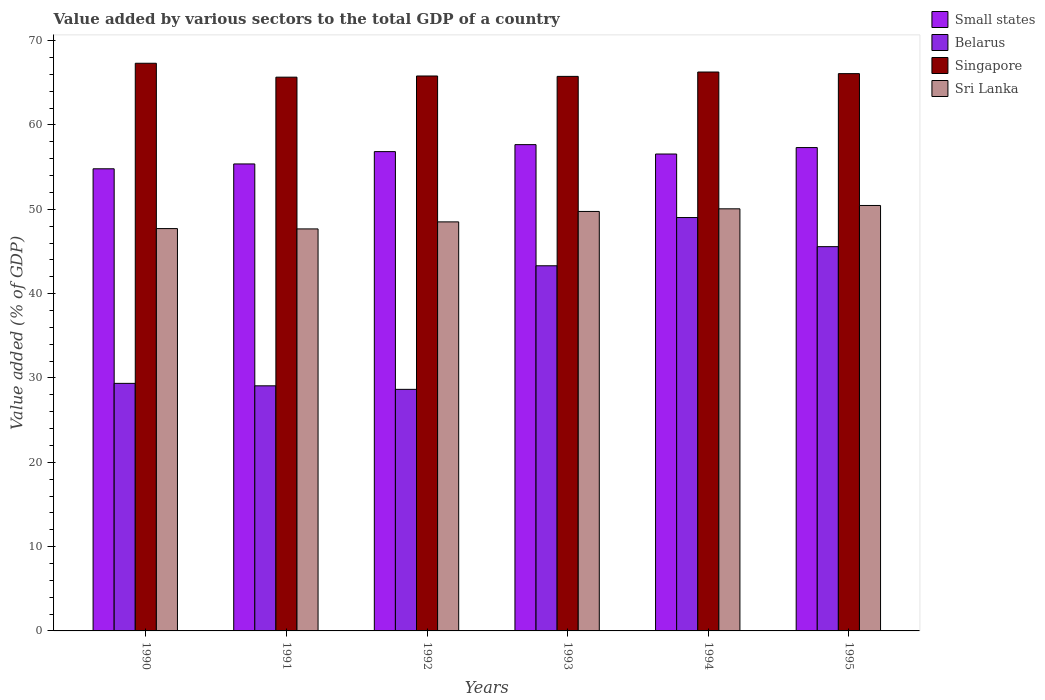Are the number of bars on each tick of the X-axis equal?
Offer a very short reply. Yes. How many bars are there on the 3rd tick from the right?
Make the answer very short. 4. In how many cases, is the number of bars for a given year not equal to the number of legend labels?
Your response must be concise. 0. What is the value added by various sectors to the total GDP in Singapore in 1990?
Ensure brevity in your answer.  67.32. Across all years, what is the maximum value added by various sectors to the total GDP in Belarus?
Make the answer very short. 49.02. Across all years, what is the minimum value added by various sectors to the total GDP in Sri Lanka?
Your answer should be compact. 47.68. In which year was the value added by various sectors to the total GDP in Singapore maximum?
Keep it short and to the point. 1990. In which year was the value added by various sectors to the total GDP in Belarus minimum?
Offer a terse response. 1992. What is the total value added by various sectors to the total GDP in Belarus in the graph?
Give a very brief answer. 224.97. What is the difference between the value added by various sectors to the total GDP in Small states in 1990 and that in 1993?
Give a very brief answer. -2.86. What is the difference between the value added by various sectors to the total GDP in Small states in 1993 and the value added by various sectors to the total GDP in Sri Lanka in 1994?
Your answer should be compact. 7.61. What is the average value added by various sectors to the total GDP in Sri Lanka per year?
Keep it short and to the point. 49.03. In the year 1992, what is the difference between the value added by various sectors to the total GDP in Small states and value added by various sectors to the total GDP in Sri Lanka?
Offer a terse response. 8.33. In how many years, is the value added by various sectors to the total GDP in Singapore greater than 54 %?
Keep it short and to the point. 6. What is the ratio of the value added by various sectors to the total GDP in Sri Lanka in 1993 to that in 1995?
Provide a short and direct response. 0.99. What is the difference between the highest and the second highest value added by various sectors to the total GDP in Belarus?
Provide a short and direct response. 3.45. What is the difference between the highest and the lowest value added by various sectors to the total GDP in Sri Lanka?
Offer a very short reply. 2.78. In how many years, is the value added by various sectors to the total GDP in Belarus greater than the average value added by various sectors to the total GDP in Belarus taken over all years?
Ensure brevity in your answer.  3. Is the sum of the value added by various sectors to the total GDP in Singapore in 1993 and 1995 greater than the maximum value added by various sectors to the total GDP in Belarus across all years?
Your answer should be very brief. Yes. What does the 4th bar from the left in 1991 represents?
Offer a very short reply. Sri Lanka. What does the 3rd bar from the right in 1992 represents?
Provide a succinct answer. Belarus. Are all the bars in the graph horizontal?
Your answer should be compact. No. What is the difference between two consecutive major ticks on the Y-axis?
Provide a succinct answer. 10. Does the graph contain grids?
Give a very brief answer. No. Where does the legend appear in the graph?
Provide a succinct answer. Top right. How many legend labels are there?
Your response must be concise. 4. How are the legend labels stacked?
Offer a terse response. Vertical. What is the title of the graph?
Your answer should be compact. Value added by various sectors to the total GDP of a country. Does "Turkey" appear as one of the legend labels in the graph?
Offer a terse response. No. What is the label or title of the Y-axis?
Provide a short and direct response. Value added (% of GDP). What is the Value added (% of GDP) of Small states in 1990?
Keep it short and to the point. 54.8. What is the Value added (% of GDP) of Belarus in 1990?
Provide a short and direct response. 29.36. What is the Value added (% of GDP) in Singapore in 1990?
Your response must be concise. 67.32. What is the Value added (% of GDP) of Sri Lanka in 1990?
Give a very brief answer. 47.71. What is the Value added (% of GDP) of Small states in 1991?
Offer a terse response. 55.38. What is the Value added (% of GDP) of Belarus in 1991?
Your answer should be very brief. 29.07. What is the Value added (% of GDP) of Singapore in 1991?
Offer a very short reply. 65.67. What is the Value added (% of GDP) in Sri Lanka in 1991?
Your answer should be compact. 47.68. What is the Value added (% of GDP) of Small states in 1992?
Your answer should be compact. 56.84. What is the Value added (% of GDP) of Belarus in 1992?
Offer a terse response. 28.65. What is the Value added (% of GDP) in Singapore in 1992?
Ensure brevity in your answer.  65.81. What is the Value added (% of GDP) of Sri Lanka in 1992?
Keep it short and to the point. 48.51. What is the Value added (% of GDP) in Small states in 1993?
Provide a succinct answer. 57.67. What is the Value added (% of GDP) in Belarus in 1993?
Provide a succinct answer. 43.3. What is the Value added (% of GDP) in Singapore in 1993?
Offer a terse response. 65.76. What is the Value added (% of GDP) of Sri Lanka in 1993?
Provide a short and direct response. 49.75. What is the Value added (% of GDP) of Small states in 1994?
Your response must be concise. 56.56. What is the Value added (% of GDP) in Belarus in 1994?
Your answer should be compact. 49.02. What is the Value added (% of GDP) in Singapore in 1994?
Provide a succinct answer. 66.28. What is the Value added (% of GDP) in Sri Lanka in 1994?
Provide a succinct answer. 50.06. What is the Value added (% of GDP) in Small states in 1995?
Keep it short and to the point. 57.32. What is the Value added (% of GDP) in Belarus in 1995?
Your answer should be very brief. 45.57. What is the Value added (% of GDP) in Singapore in 1995?
Your answer should be very brief. 66.09. What is the Value added (% of GDP) in Sri Lanka in 1995?
Provide a short and direct response. 50.46. Across all years, what is the maximum Value added (% of GDP) of Small states?
Keep it short and to the point. 57.67. Across all years, what is the maximum Value added (% of GDP) of Belarus?
Ensure brevity in your answer.  49.02. Across all years, what is the maximum Value added (% of GDP) of Singapore?
Give a very brief answer. 67.32. Across all years, what is the maximum Value added (% of GDP) in Sri Lanka?
Give a very brief answer. 50.46. Across all years, what is the minimum Value added (% of GDP) of Small states?
Your answer should be compact. 54.8. Across all years, what is the minimum Value added (% of GDP) of Belarus?
Provide a short and direct response. 28.65. Across all years, what is the minimum Value added (% of GDP) of Singapore?
Your answer should be compact. 65.67. Across all years, what is the minimum Value added (% of GDP) of Sri Lanka?
Offer a terse response. 47.68. What is the total Value added (% of GDP) in Small states in the graph?
Offer a very short reply. 338.57. What is the total Value added (% of GDP) in Belarus in the graph?
Keep it short and to the point. 224.97. What is the total Value added (% of GDP) of Singapore in the graph?
Make the answer very short. 396.94. What is the total Value added (% of GDP) of Sri Lanka in the graph?
Make the answer very short. 294.16. What is the difference between the Value added (% of GDP) in Small states in 1990 and that in 1991?
Provide a succinct answer. -0.58. What is the difference between the Value added (% of GDP) in Belarus in 1990 and that in 1991?
Your answer should be compact. 0.29. What is the difference between the Value added (% of GDP) in Singapore in 1990 and that in 1991?
Your response must be concise. 1.65. What is the difference between the Value added (% of GDP) in Sri Lanka in 1990 and that in 1991?
Ensure brevity in your answer.  0.04. What is the difference between the Value added (% of GDP) in Small states in 1990 and that in 1992?
Give a very brief answer. -2.04. What is the difference between the Value added (% of GDP) in Belarus in 1990 and that in 1992?
Make the answer very short. 0.71. What is the difference between the Value added (% of GDP) of Singapore in 1990 and that in 1992?
Your answer should be compact. 1.51. What is the difference between the Value added (% of GDP) in Sri Lanka in 1990 and that in 1992?
Your response must be concise. -0.8. What is the difference between the Value added (% of GDP) in Small states in 1990 and that in 1993?
Your answer should be very brief. -2.86. What is the difference between the Value added (% of GDP) of Belarus in 1990 and that in 1993?
Keep it short and to the point. -13.95. What is the difference between the Value added (% of GDP) in Singapore in 1990 and that in 1993?
Offer a very short reply. 1.56. What is the difference between the Value added (% of GDP) in Sri Lanka in 1990 and that in 1993?
Provide a succinct answer. -2.03. What is the difference between the Value added (% of GDP) of Small states in 1990 and that in 1994?
Keep it short and to the point. -1.75. What is the difference between the Value added (% of GDP) of Belarus in 1990 and that in 1994?
Provide a short and direct response. -19.67. What is the difference between the Value added (% of GDP) of Singapore in 1990 and that in 1994?
Your answer should be compact. 1.04. What is the difference between the Value added (% of GDP) of Sri Lanka in 1990 and that in 1994?
Ensure brevity in your answer.  -2.34. What is the difference between the Value added (% of GDP) of Small states in 1990 and that in 1995?
Keep it short and to the point. -2.52. What is the difference between the Value added (% of GDP) in Belarus in 1990 and that in 1995?
Give a very brief answer. -16.21. What is the difference between the Value added (% of GDP) of Singapore in 1990 and that in 1995?
Your answer should be compact. 1.23. What is the difference between the Value added (% of GDP) in Sri Lanka in 1990 and that in 1995?
Your answer should be compact. -2.74. What is the difference between the Value added (% of GDP) in Small states in 1991 and that in 1992?
Keep it short and to the point. -1.46. What is the difference between the Value added (% of GDP) in Belarus in 1991 and that in 1992?
Provide a short and direct response. 0.42. What is the difference between the Value added (% of GDP) of Singapore in 1991 and that in 1992?
Make the answer very short. -0.14. What is the difference between the Value added (% of GDP) of Sri Lanka in 1991 and that in 1992?
Provide a succinct answer. -0.83. What is the difference between the Value added (% of GDP) in Small states in 1991 and that in 1993?
Offer a very short reply. -2.29. What is the difference between the Value added (% of GDP) in Belarus in 1991 and that in 1993?
Your answer should be compact. -14.24. What is the difference between the Value added (% of GDP) of Singapore in 1991 and that in 1993?
Your answer should be compact. -0.09. What is the difference between the Value added (% of GDP) of Sri Lanka in 1991 and that in 1993?
Provide a short and direct response. -2.07. What is the difference between the Value added (% of GDP) in Small states in 1991 and that in 1994?
Ensure brevity in your answer.  -1.18. What is the difference between the Value added (% of GDP) in Belarus in 1991 and that in 1994?
Ensure brevity in your answer.  -19.96. What is the difference between the Value added (% of GDP) of Singapore in 1991 and that in 1994?
Your answer should be very brief. -0.61. What is the difference between the Value added (% of GDP) of Sri Lanka in 1991 and that in 1994?
Keep it short and to the point. -2.38. What is the difference between the Value added (% of GDP) in Small states in 1991 and that in 1995?
Keep it short and to the point. -1.94. What is the difference between the Value added (% of GDP) in Belarus in 1991 and that in 1995?
Offer a terse response. -16.5. What is the difference between the Value added (% of GDP) of Singapore in 1991 and that in 1995?
Your response must be concise. -0.42. What is the difference between the Value added (% of GDP) in Sri Lanka in 1991 and that in 1995?
Your answer should be very brief. -2.78. What is the difference between the Value added (% of GDP) of Small states in 1992 and that in 1993?
Your answer should be very brief. -0.83. What is the difference between the Value added (% of GDP) in Belarus in 1992 and that in 1993?
Your answer should be compact. -14.66. What is the difference between the Value added (% of GDP) in Singapore in 1992 and that in 1993?
Ensure brevity in your answer.  0.05. What is the difference between the Value added (% of GDP) in Sri Lanka in 1992 and that in 1993?
Offer a very short reply. -1.24. What is the difference between the Value added (% of GDP) in Small states in 1992 and that in 1994?
Your answer should be compact. 0.28. What is the difference between the Value added (% of GDP) in Belarus in 1992 and that in 1994?
Make the answer very short. -20.38. What is the difference between the Value added (% of GDP) of Singapore in 1992 and that in 1994?
Keep it short and to the point. -0.47. What is the difference between the Value added (% of GDP) of Sri Lanka in 1992 and that in 1994?
Your answer should be very brief. -1.55. What is the difference between the Value added (% of GDP) of Small states in 1992 and that in 1995?
Provide a short and direct response. -0.48. What is the difference between the Value added (% of GDP) in Belarus in 1992 and that in 1995?
Provide a succinct answer. -16.92. What is the difference between the Value added (% of GDP) in Singapore in 1992 and that in 1995?
Offer a very short reply. -0.28. What is the difference between the Value added (% of GDP) in Sri Lanka in 1992 and that in 1995?
Ensure brevity in your answer.  -1.95. What is the difference between the Value added (% of GDP) of Small states in 1993 and that in 1994?
Your response must be concise. 1.11. What is the difference between the Value added (% of GDP) of Belarus in 1993 and that in 1994?
Offer a very short reply. -5.72. What is the difference between the Value added (% of GDP) of Singapore in 1993 and that in 1994?
Provide a succinct answer. -0.52. What is the difference between the Value added (% of GDP) in Sri Lanka in 1993 and that in 1994?
Make the answer very short. -0.31. What is the difference between the Value added (% of GDP) of Small states in 1993 and that in 1995?
Your response must be concise. 0.35. What is the difference between the Value added (% of GDP) of Belarus in 1993 and that in 1995?
Keep it short and to the point. -2.27. What is the difference between the Value added (% of GDP) of Singapore in 1993 and that in 1995?
Provide a succinct answer. -0.33. What is the difference between the Value added (% of GDP) of Sri Lanka in 1993 and that in 1995?
Your response must be concise. -0.71. What is the difference between the Value added (% of GDP) in Small states in 1994 and that in 1995?
Offer a terse response. -0.77. What is the difference between the Value added (% of GDP) of Belarus in 1994 and that in 1995?
Provide a succinct answer. 3.45. What is the difference between the Value added (% of GDP) in Singapore in 1994 and that in 1995?
Provide a short and direct response. 0.19. What is the difference between the Value added (% of GDP) of Sri Lanka in 1994 and that in 1995?
Ensure brevity in your answer.  -0.4. What is the difference between the Value added (% of GDP) of Small states in 1990 and the Value added (% of GDP) of Belarus in 1991?
Your answer should be compact. 25.74. What is the difference between the Value added (% of GDP) in Small states in 1990 and the Value added (% of GDP) in Singapore in 1991?
Make the answer very short. -10.87. What is the difference between the Value added (% of GDP) in Small states in 1990 and the Value added (% of GDP) in Sri Lanka in 1991?
Provide a short and direct response. 7.13. What is the difference between the Value added (% of GDP) in Belarus in 1990 and the Value added (% of GDP) in Singapore in 1991?
Your response must be concise. -36.31. What is the difference between the Value added (% of GDP) of Belarus in 1990 and the Value added (% of GDP) of Sri Lanka in 1991?
Ensure brevity in your answer.  -18.32. What is the difference between the Value added (% of GDP) of Singapore in 1990 and the Value added (% of GDP) of Sri Lanka in 1991?
Offer a terse response. 19.64. What is the difference between the Value added (% of GDP) of Small states in 1990 and the Value added (% of GDP) of Belarus in 1992?
Offer a very short reply. 26.16. What is the difference between the Value added (% of GDP) of Small states in 1990 and the Value added (% of GDP) of Singapore in 1992?
Give a very brief answer. -11.01. What is the difference between the Value added (% of GDP) of Small states in 1990 and the Value added (% of GDP) of Sri Lanka in 1992?
Provide a short and direct response. 6.29. What is the difference between the Value added (% of GDP) in Belarus in 1990 and the Value added (% of GDP) in Singapore in 1992?
Offer a terse response. -36.45. What is the difference between the Value added (% of GDP) of Belarus in 1990 and the Value added (% of GDP) of Sri Lanka in 1992?
Ensure brevity in your answer.  -19.15. What is the difference between the Value added (% of GDP) of Singapore in 1990 and the Value added (% of GDP) of Sri Lanka in 1992?
Offer a very short reply. 18.81. What is the difference between the Value added (% of GDP) of Small states in 1990 and the Value added (% of GDP) of Belarus in 1993?
Your response must be concise. 11.5. What is the difference between the Value added (% of GDP) in Small states in 1990 and the Value added (% of GDP) in Singapore in 1993?
Your response must be concise. -10.96. What is the difference between the Value added (% of GDP) of Small states in 1990 and the Value added (% of GDP) of Sri Lanka in 1993?
Provide a succinct answer. 5.06. What is the difference between the Value added (% of GDP) in Belarus in 1990 and the Value added (% of GDP) in Singapore in 1993?
Provide a short and direct response. -36.41. What is the difference between the Value added (% of GDP) of Belarus in 1990 and the Value added (% of GDP) of Sri Lanka in 1993?
Your answer should be very brief. -20.39. What is the difference between the Value added (% of GDP) of Singapore in 1990 and the Value added (% of GDP) of Sri Lanka in 1993?
Keep it short and to the point. 17.57. What is the difference between the Value added (% of GDP) of Small states in 1990 and the Value added (% of GDP) of Belarus in 1994?
Provide a short and direct response. 5.78. What is the difference between the Value added (% of GDP) of Small states in 1990 and the Value added (% of GDP) of Singapore in 1994?
Your answer should be compact. -11.48. What is the difference between the Value added (% of GDP) of Small states in 1990 and the Value added (% of GDP) of Sri Lanka in 1994?
Your answer should be very brief. 4.75. What is the difference between the Value added (% of GDP) of Belarus in 1990 and the Value added (% of GDP) of Singapore in 1994?
Provide a succinct answer. -36.92. What is the difference between the Value added (% of GDP) of Belarus in 1990 and the Value added (% of GDP) of Sri Lanka in 1994?
Your response must be concise. -20.7. What is the difference between the Value added (% of GDP) of Singapore in 1990 and the Value added (% of GDP) of Sri Lanka in 1994?
Offer a terse response. 17.26. What is the difference between the Value added (% of GDP) of Small states in 1990 and the Value added (% of GDP) of Belarus in 1995?
Your answer should be very brief. 9.23. What is the difference between the Value added (% of GDP) of Small states in 1990 and the Value added (% of GDP) of Singapore in 1995?
Provide a succinct answer. -11.29. What is the difference between the Value added (% of GDP) of Small states in 1990 and the Value added (% of GDP) of Sri Lanka in 1995?
Your answer should be very brief. 4.35. What is the difference between the Value added (% of GDP) of Belarus in 1990 and the Value added (% of GDP) of Singapore in 1995?
Give a very brief answer. -36.73. What is the difference between the Value added (% of GDP) of Belarus in 1990 and the Value added (% of GDP) of Sri Lanka in 1995?
Make the answer very short. -21.1. What is the difference between the Value added (% of GDP) of Singapore in 1990 and the Value added (% of GDP) of Sri Lanka in 1995?
Ensure brevity in your answer.  16.87. What is the difference between the Value added (% of GDP) of Small states in 1991 and the Value added (% of GDP) of Belarus in 1992?
Make the answer very short. 26.73. What is the difference between the Value added (% of GDP) of Small states in 1991 and the Value added (% of GDP) of Singapore in 1992?
Your response must be concise. -10.43. What is the difference between the Value added (% of GDP) of Small states in 1991 and the Value added (% of GDP) of Sri Lanka in 1992?
Provide a succinct answer. 6.87. What is the difference between the Value added (% of GDP) of Belarus in 1991 and the Value added (% of GDP) of Singapore in 1992?
Keep it short and to the point. -36.74. What is the difference between the Value added (% of GDP) in Belarus in 1991 and the Value added (% of GDP) in Sri Lanka in 1992?
Keep it short and to the point. -19.44. What is the difference between the Value added (% of GDP) in Singapore in 1991 and the Value added (% of GDP) in Sri Lanka in 1992?
Make the answer very short. 17.16. What is the difference between the Value added (% of GDP) of Small states in 1991 and the Value added (% of GDP) of Belarus in 1993?
Provide a short and direct response. 12.08. What is the difference between the Value added (% of GDP) in Small states in 1991 and the Value added (% of GDP) in Singapore in 1993?
Your answer should be very brief. -10.38. What is the difference between the Value added (% of GDP) of Small states in 1991 and the Value added (% of GDP) of Sri Lanka in 1993?
Offer a very short reply. 5.63. What is the difference between the Value added (% of GDP) in Belarus in 1991 and the Value added (% of GDP) in Singapore in 1993?
Provide a short and direct response. -36.7. What is the difference between the Value added (% of GDP) of Belarus in 1991 and the Value added (% of GDP) of Sri Lanka in 1993?
Keep it short and to the point. -20.68. What is the difference between the Value added (% of GDP) in Singapore in 1991 and the Value added (% of GDP) in Sri Lanka in 1993?
Your response must be concise. 15.92. What is the difference between the Value added (% of GDP) in Small states in 1991 and the Value added (% of GDP) in Belarus in 1994?
Give a very brief answer. 6.36. What is the difference between the Value added (% of GDP) in Small states in 1991 and the Value added (% of GDP) in Singapore in 1994?
Make the answer very short. -10.9. What is the difference between the Value added (% of GDP) in Small states in 1991 and the Value added (% of GDP) in Sri Lanka in 1994?
Keep it short and to the point. 5.32. What is the difference between the Value added (% of GDP) of Belarus in 1991 and the Value added (% of GDP) of Singapore in 1994?
Make the answer very short. -37.21. What is the difference between the Value added (% of GDP) in Belarus in 1991 and the Value added (% of GDP) in Sri Lanka in 1994?
Keep it short and to the point. -20.99. What is the difference between the Value added (% of GDP) in Singapore in 1991 and the Value added (% of GDP) in Sri Lanka in 1994?
Your answer should be compact. 15.61. What is the difference between the Value added (% of GDP) of Small states in 1991 and the Value added (% of GDP) of Belarus in 1995?
Make the answer very short. 9.81. What is the difference between the Value added (% of GDP) of Small states in 1991 and the Value added (% of GDP) of Singapore in 1995?
Make the answer very short. -10.71. What is the difference between the Value added (% of GDP) in Small states in 1991 and the Value added (% of GDP) in Sri Lanka in 1995?
Offer a very short reply. 4.92. What is the difference between the Value added (% of GDP) of Belarus in 1991 and the Value added (% of GDP) of Singapore in 1995?
Your answer should be very brief. -37.02. What is the difference between the Value added (% of GDP) of Belarus in 1991 and the Value added (% of GDP) of Sri Lanka in 1995?
Provide a succinct answer. -21.39. What is the difference between the Value added (% of GDP) of Singapore in 1991 and the Value added (% of GDP) of Sri Lanka in 1995?
Offer a terse response. 15.22. What is the difference between the Value added (% of GDP) of Small states in 1992 and the Value added (% of GDP) of Belarus in 1993?
Ensure brevity in your answer.  13.54. What is the difference between the Value added (% of GDP) in Small states in 1992 and the Value added (% of GDP) in Singapore in 1993?
Offer a very short reply. -8.92. What is the difference between the Value added (% of GDP) in Small states in 1992 and the Value added (% of GDP) in Sri Lanka in 1993?
Ensure brevity in your answer.  7.1. What is the difference between the Value added (% of GDP) of Belarus in 1992 and the Value added (% of GDP) of Singapore in 1993?
Your response must be concise. -37.12. What is the difference between the Value added (% of GDP) in Belarus in 1992 and the Value added (% of GDP) in Sri Lanka in 1993?
Provide a succinct answer. -21.1. What is the difference between the Value added (% of GDP) of Singapore in 1992 and the Value added (% of GDP) of Sri Lanka in 1993?
Make the answer very short. 16.06. What is the difference between the Value added (% of GDP) in Small states in 1992 and the Value added (% of GDP) in Belarus in 1994?
Ensure brevity in your answer.  7.82. What is the difference between the Value added (% of GDP) of Small states in 1992 and the Value added (% of GDP) of Singapore in 1994?
Provide a short and direct response. -9.44. What is the difference between the Value added (% of GDP) in Small states in 1992 and the Value added (% of GDP) in Sri Lanka in 1994?
Your response must be concise. 6.78. What is the difference between the Value added (% of GDP) of Belarus in 1992 and the Value added (% of GDP) of Singapore in 1994?
Offer a terse response. -37.63. What is the difference between the Value added (% of GDP) of Belarus in 1992 and the Value added (% of GDP) of Sri Lanka in 1994?
Your answer should be compact. -21.41. What is the difference between the Value added (% of GDP) in Singapore in 1992 and the Value added (% of GDP) in Sri Lanka in 1994?
Offer a very short reply. 15.75. What is the difference between the Value added (% of GDP) of Small states in 1992 and the Value added (% of GDP) of Belarus in 1995?
Give a very brief answer. 11.27. What is the difference between the Value added (% of GDP) in Small states in 1992 and the Value added (% of GDP) in Singapore in 1995?
Keep it short and to the point. -9.25. What is the difference between the Value added (% of GDP) of Small states in 1992 and the Value added (% of GDP) of Sri Lanka in 1995?
Your answer should be compact. 6.39. What is the difference between the Value added (% of GDP) in Belarus in 1992 and the Value added (% of GDP) in Singapore in 1995?
Your answer should be very brief. -37.44. What is the difference between the Value added (% of GDP) in Belarus in 1992 and the Value added (% of GDP) in Sri Lanka in 1995?
Offer a terse response. -21.81. What is the difference between the Value added (% of GDP) in Singapore in 1992 and the Value added (% of GDP) in Sri Lanka in 1995?
Your answer should be very brief. 15.36. What is the difference between the Value added (% of GDP) in Small states in 1993 and the Value added (% of GDP) in Belarus in 1994?
Give a very brief answer. 8.65. What is the difference between the Value added (% of GDP) in Small states in 1993 and the Value added (% of GDP) in Singapore in 1994?
Provide a succinct answer. -8.61. What is the difference between the Value added (% of GDP) of Small states in 1993 and the Value added (% of GDP) of Sri Lanka in 1994?
Keep it short and to the point. 7.61. What is the difference between the Value added (% of GDP) of Belarus in 1993 and the Value added (% of GDP) of Singapore in 1994?
Offer a very short reply. -22.98. What is the difference between the Value added (% of GDP) in Belarus in 1993 and the Value added (% of GDP) in Sri Lanka in 1994?
Make the answer very short. -6.75. What is the difference between the Value added (% of GDP) of Singapore in 1993 and the Value added (% of GDP) of Sri Lanka in 1994?
Offer a very short reply. 15.71. What is the difference between the Value added (% of GDP) in Small states in 1993 and the Value added (% of GDP) in Belarus in 1995?
Provide a short and direct response. 12.1. What is the difference between the Value added (% of GDP) of Small states in 1993 and the Value added (% of GDP) of Singapore in 1995?
Make the answer very short. -8.42. What is the difference between the Value added (% of GDP) of Small states in 1993 and the Value added (% of GDP) of Sri Lanka in 1995?
Keep it short and to the point. 7.21. What is the difference between the Value added (% of GDP) of Belarus in 1993 and the Value added (% of GDP) of Singapore in 1995?
Give a very brief answer. -22.79. What is the difference between the Value added (% of GDP) of Belarus in 1993 and the Value added (% of GDP) of Sri Lanka in 1995?
Keep it short and to the point. -7.15. What is the difference between the Value added (% of GDP) in Singapore in 1993 and the Value added (% of GDP) in Sri Lanka in 1995?
Your answer should be compact. 15.31. What is the difference between the Value added (% of GDP) of Small states in 1994 and the Value added (% of GDP) of Belarus in 1995?
Offer a terse response. 10.99. What is the difference between the Value added (% of GDP) of Small states in 1994 and the Value added (% of GDP) of Singapore in 1995?
Offer a very short reply. -9.53. What is the difference between the Value added (% of GDP) in Small states in 1994 and the Value added (% of GDP) in Sri Lanka in 1995?
Offer a very short reply. 6.1. What is the difference between the Value added (% of GDP) of Belarus in 1994 and the Value added (% of GDP) of Singapore in 1995?
Offer a very short reply. -17.07. What is the difference between the Value added (% of GDP) in Belarus in 1994 and the Value added (% of GDP) in Sri Lanka in 1995?
Provide a short and direct response. -1.43. What is the difference between the Value added (% of GDP) in Singapore in 1994 and the Value added (% of GDP) in Sri Lanka in 1995?
Give a very brief answer. 15.83. What is the average Value added (% of GDP) in Small states per year?
Give a very brief answer. 56.43. What is the average Value added (% of GDP) of Belarus per year?
Your answer should be compact. 37.5. What is the average Value added (% of GDP) in Singapore per year?
Your answer should be very brief. 66.16. What is the average Value added (% of GDP) in Sri Lanka per year?
Offer a very short reply. 49.03. In the year 1990, what is the difference between the Value added (% of GDP) in Small states and Value added (% of GDP) in Belarus?
Provide a short and direct response. 25.45. In the year 1990, what is the difference between the Value added (% of GDP) of Small states and Value added (% of GDP) of Singapore?
Your answer should be very brief. -12.52. In the year 1990, what is the difference between the Value added (% of GDP) of Small states and Value added (% of GDP) of Sri Lanka?
Offer a very short reply. 7.09. In the year 1990, what is the difference between the Value added (% of GDP) of Belarus and Value added (% of GDP) of Singapore?
Make the answer very short. -37.96. In the year 1990, what is the difference between the Value added (% of GDP) in Belarus and Value added (% of GDP) in Sri Lanka?
Give a very brief answer. -18.36. In the year 1990, what is the difference between the Value added (% of GDP) of Singapore and Value added (% of GDP) of Sri Lanka?
Your answer should be compact. 19.61. In the year 1991, what is the difference between the Value added (% of GDP) of Small states and Value added (% of GDP) of Belarus?
Make the answer very short. 26.31. In the year 1991, what is the difference between the Value added (% of GDP) of Small states and Value added (% of GDP) of Singapore?
Make the answer very short. -10.29. In the year 1991, what is the difference between the Value added (% of GDP) of Small states and Value added (% of GDP) of Sri Lanka?
Your answer should be very brief. 7.7. In the year 1991, what is the difference between the Value added (% of GDP) in Belarus and Value added (% of GDP) in Singapore?
Keep it short and to the point. -36.6. In the year 1991, what is the difference between the Value added (% of GDP) of Belarus and Value added (% of GDP) of Sri Lanka?
Keep it short and to the point. -18.61. In the year 1991, what is the difference between the Value added (% of GDP) of Singapore and Value added (% of GDP) of Sri Lanka?
Offer a terse response. 17.99. In the year 1992, what is the difference between the Value added (% of GDP) of Small states and Value added (% of GDP) of Belarus?
Your response must be concise. 28.19. In the year 1992, what is the difference between the Value added (% of GDP) in Small states and Value added (% of GDP) in Singapore?
Provide a succinct answer. -8.97. In the year 1992, what is the difference between the Value added (% of GDP) of Small states and Value added (% of GDP) of Sri Lanka?
Your answer should be compact. 8.33. In the year 1992, what is the difference between the Value added (% of GDP) of Belarus and Value added (% of GDP) of Singapore?
Your answer should be compact. -37.16. In the year 1992, what is the difference between the Value added (% of GDP) of Belarus and Value added (% of GDP) of Sri Lanka?
Provide a succinct answer. -19.86. In the year 1992, what is the difference between the Value added (% of GDP) of Singapore and Value added (% of GDP) of Sri Lanka?
Provide a short and direct response. 17.3. In the year 1993, what is the difference between the Value added (% of GDP) in Small states and Value added (% of GDP) in Belarus?
Ensure brevity in your answer.  14.37. In the year 1993, what is the difference between the Value added (% of GDP) of Small states and Value added (% of GDP) of Singapore?
Keep it short and to the point. -8.09. In the year 1993, what is the difference between the Value added (% of GDP) in Small states and Value added (% of GDP) in Sri Lanka?
Provide a short and direct response. 7.92. In the year 1993, what is the difference between the Value added (% of GDP) of Belarus and Value added (% of GDP) of Singapore?
Offer a terse response. -22.46. In the year 1993, what is the difference between the Value added (% of GDP) in Belarus and Value added (% of GDP) in Sri Lanka?
Make the answer very short. -6.44. In the year 1993, what is the difference between the Value added (% of GDP) in Singapore and Value added (% of GDP) in Sri Lanka?
Ensure brevity in your answer.  16.02. In the year 1994, what is the difference between the Value added (% of GDP) in Small states and Value added (% of GDP) in Belarus?
Make the answer very short. 7.53. In the year 1994, what is the difference between the Value added (% of GDP) of Small states and Value added (% of GDP) of Singapore?
Your response must be concise. -9.72. In the year 1994, what is the difference between the Value added (% of GDP) of Small states and Value added (% of GDP) of Sri Lanka?
Make the answer very short. 6.5. In the year 1994, what is the difference between the Value added (% of GDP) in Belarus and Value added (% of GDP) in Singapore?
Your answer should be very brief. -17.26. In the year 1994, what is the difference between the Value added (% of GDP) of Belarus and Value added (% of GDP) of Sri Lanka?
Keep it short and to the point. -1.03. In the year 1994, what is the difference between the Value added (% of GDP) in Singapore and Value added (% of GDP) in Sri Lanka?
Provide a succinct answer. 16.22. In the year 1995, what is the difference between the Value added (% of GDP) of Small states and Value added (% of GDP) of Belarus?
Your answer should be compact. 11.75. In the year 1995, what is the difference between the Value added (% of GDP) in Small states and Value added (% of GDP) in Singapore?
Offer a terse response. -8.77. In the year 1995, what is the difference between the Value added (% of GDP) in Small states and Value added (% of GDP) in Sri Lanka?
Ensure brevity in your answer.  6.87. In the year 1995, what is the difference between the Value added (% of GDP) of Belarus and Value added (% of GDP) of Singapore?
Your response must be concise. -20.52. In the year 1995, what is the difference between the Value added (% of GDP) in Belarus and Value added (% of GDP) in Sri Lanka?
Your answer should be very brief. -4.88. In the year 1995, what is the difference between the Value added (% of GDP) of Singapore and Value added (% of GDP) of Sri Lanka?
Make the answer very short. 15.64. What is the ratio of the Value added (% of GDP) in Small states in 1990 to that in 1991?
Provide a short and direct response. 0.99. What is the ratio of the Value added (% of GDP) of Singapore in 1990 to that in 1991?
Offer a very short reply. 1.03. What is the ratio of the Value added (% of GDP) in Small states in 1990 to that in 1992?
Provide a short and direct response. 0.96. What is the ratio of the Value added (% of GDP) of Belarus in 1990 to that in 1992?
Ensure brevity in your answer.  1.02. What is the ratio of the Value added (% of GDP) of Singapore in 1990 to that in 1992?
Offer a terse response. 1.02. What is the ratio of the Value added (% of GDP) in Sri Lanka in 1990 to that in 1992?
Offer a terse response. 0.98. What is the ratio of the Value added (% of GDP) in Small states in 1990 to that in 1993?
Your response must be concise. 0.95. What is the ratio of the Value added (% of GDP) of Belarus in 1990 to that in 1993?
Provide a succinct answer. 0.68. What is the ratio of the Value added (% of GDP) in Singapore in 1990 to that in 1993?
Provide a succinct answer. 1.02. What is the ratio of the Value added (% of GDP) in Sri Lanka in 1990 to that in 1993?
Keep it short and to the point. 0.96. What is the ratio of the Value added (% of GDP) of Belarus in 1990 to that in 1994?
Keep it short and to the point. 0.6. What is the ratio of the Value added (% of GDP) of Singapore in 1990 to that in 1994?
Provide a short and direct response. 1.02. What is the ratio of the Value added (% of GDP) of Sri Lanka in 1990 to that in 1994?
Make the answer very short. 0.95. What is the ratio of the Value added (% of GDP) of Small states in 1990 to that in 1995?
Offer a terse response. 0.96. What is the ratio of the Value added (% of GDP) of Belarus in 1990 to that in 1995?
Give a very brief answer. 0.64. What is the ratio of the Value added (% of GDP) of Singapore in 1990 to that in 1995?
Give a very brief answer. 1.02. What is the ratio of the Value added (% of GDP) of Sri Lanka in 1990 to that in 1995?
Your answer should be compact. 0.95. What is the ratio of the Value added (% of GDP) in Small states in 1991 to that in 1992?
Make the answer very short. 0.97. What is the ratio of the Value added (% of GDP) of Belarus in 1991 to that in 1992?
Your answer should be very brief. 1.01. What is the ratio of the Value added (% of GDP) in Sri Lanka in 1991 to that in 1992?
Your answer should be very brief. 0.98. What is the ratio of the Value added (% of GDP) of Small states in 1991 to that in 1993?
Your response must be concise. 0.96. What is the ratio of the Value added (% of GDP) in Belarus in 1991 to that in 1993?
Provide a short and direct response. 0.67. What is the ratio of the Value added (% of GDP) of Singapore in 1991 to that in 1993?
Give a very brief answer. 1. What is the ratio of the Value added (% of GDP) of Sri Lanka in 1991 to that in 1993?
Offer a very short reply. 0.96. What is the ratio of the Value added (% of GDP) of Small states in 1991 to that in 1994?
Provide a succinct answer. 0.98. What is the ratio of the Value added (% of GDP) of Belarus in 1991 to that in 1994?
Make the answer very short. 0.59. What is the ratio of the Value added (% of GDP) of Singapore in 1991 to that in 1994?
Provide a succinct answer. 0.99. What is the ratio of the Value added (% of GDP) in Small states in 1991 to that in 1995?
Your answer should be compact. 0.97. What is the ratio of the Value added (% of GDP) in Belarus in 1991 to that in 1995?
Give a very brief answer. 0.64. What is the ratio of the Value added (% of GDP) in Singapore in 1991 to that in 1995?
Offer a terse response. 0.99. What is the ratio of the Value added (% of GDP) in Sri Lanka in 1991 to that in 1995?
Provide a short and direct response. 0.94. What is the ratio of the Value added (% of GDP) of Small states in 1992 to that in 1993?
Your response must be concise. 0.99. What is the ratio of the Value added (% of GDP) in Belarus in 1992 to that in 1993?
Make the answer very short. 0.66. What is the ratio of the Value added (% of GDP) in Singapore in 1992 to that in 1993?
Offer a very short reply. 1. What is the ratio of the Value added (% of GDP) of Sri Lanka in 1992 to that in 1993?
Give a very brief answer. 0.98. What is the ratio of the Value added (% of GDP) of Belarus in 1992 to that in 1994?
Your answer should be compact. 0.58. What is the ratio of the Value added (% of GDP) of Singapore in 1992 to that in 1994?
Make the answer very short. 0.99. What is the ratio of the Value added (% of GDP) in Sri Lanka in 1992 to that in 1994?
Keep it short and to the point. 0.97. What is the ratio of the Value added (% of GDP) in Small states in 1992 to that in 1995?
Give a very brief answer. 0.99. What is the ratio of the Value added (% of GDP) of Belarus in 1992 to that in 1995?
Keep it short and to the point. 0.63. What is the ratio of the Value added (% of GDP) of Singapore in 1992 to that in 1995?
Your answer should be compact. 1. What is the ratio of the Value added (% of GDP) of Sri Lanka in 1992 to that in 1995?
Make the answer very short. 0.96. What is the ratio of the Value added (% of GDP) of Small states in 1993 to that in 1994?
Provide a short and direct response. 1.02. What is the ratio of the Value added (% of GDP) of Belarus in 1993 to that in 1994?
Your answer should be very brief. 0.88. What is the ratio of the Value added (% of GDP) of Singapore in 1993 to that in 1994?
Make the answer very short. 0.99. What is the ratio of the Value added (% of GDP) of Belarus in 1993 to that in 1995?
Provide a short and direct response. 0.95. What is the ratio of the Value added (% of GDP) of Singapore in 1993 to that in 1995?
Keep it short and to the point. 1. What is the ratio of the Value added (% of GDP) in Sri Lanka in 1993 to that in 1995?
Your response must be concise. 0.99. What is the ratio of the Value added (% of GDP) in Small states in 1994 to that in 1995?
Make the answer very short. 0.99. What is the ratio of the Value added (% of GDP) of Belarus in 1994 to that in 1995?
Ensure brevity in your answer.  1.08. What is the ratio of the Value added (% of GDP) of Sri Lanka in 1994 to that in 1995?
Ensure brevity in your answer.  0.99. What is the difference between the highest and the second highest Value added (% of GDP) of Small states?
Give a very brief answer. 0.35. What is the difference between the highest and the second highest Value added (% of GDP) of Belarus?
Provide a short and direct response. 3.45. What is the difference between the highest and the second highest Value added (% of GDP) of Singapore?
Provide a short and direct response. 1.04. What is the difference between the highest and the second highest Value added (% of GDP) of Sri Lanka?
Keep it short and to the point. 0.4. What is the difference between the highest and the lowest Value added (% of GDP) of Small states?
Provide a succinct answer. 2.86. What is the difference between the highest and the lowest Value added (% of GDP) of Belarus?
Give a very brief answer. 20.38. What is the difference between the highest and the lowest Value added (% of GDP) of Singapore?
Offer a terse response. 1.65. What is the difference between the highest and the lowest Value added (% of GDP) of Sri Lanka?
Your answer should be compact. 2.78. 